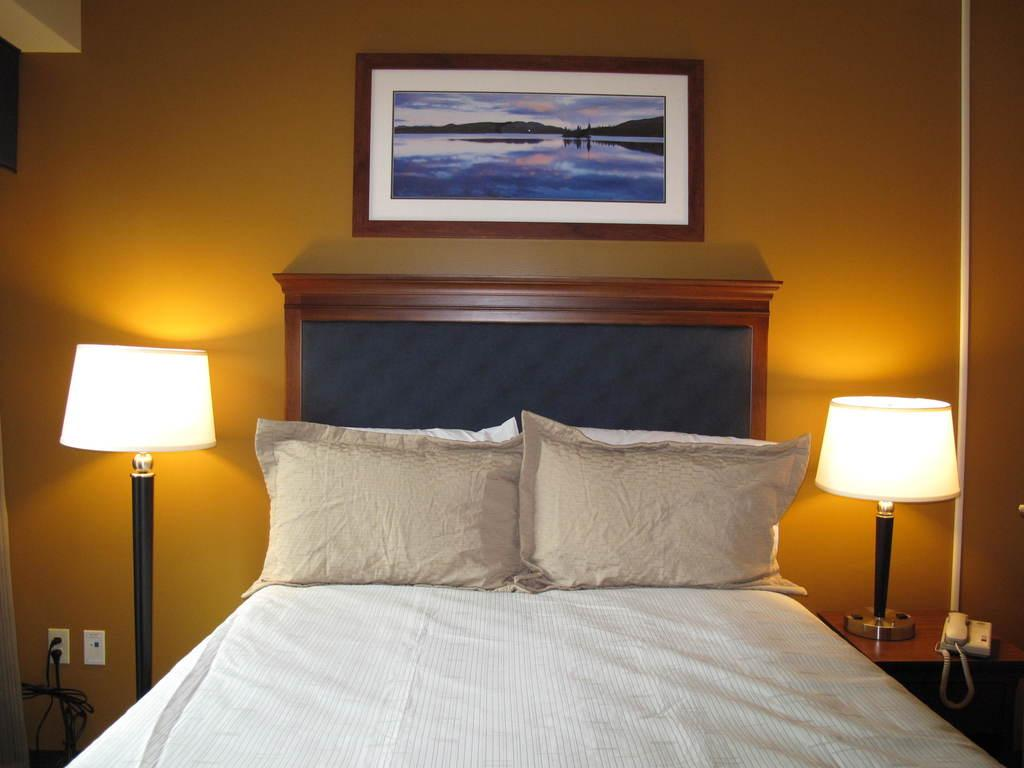What type of room is shown in the image? The image depicts a bedroom. What furniture is present in the bedroom? There is a bed with two pillows, and there are two lamps, one on either side of the bed. What decorative item can be seen on the wall? There is a photo frame on the wall. What device is present on a table in the bedroom? There is a telephone on a table in the bedroom. What type of trade is being conducted in the bedroom? There is no indication of any trade being conducted in the bedroom; the image only shows a bedroom with its furnishings. 